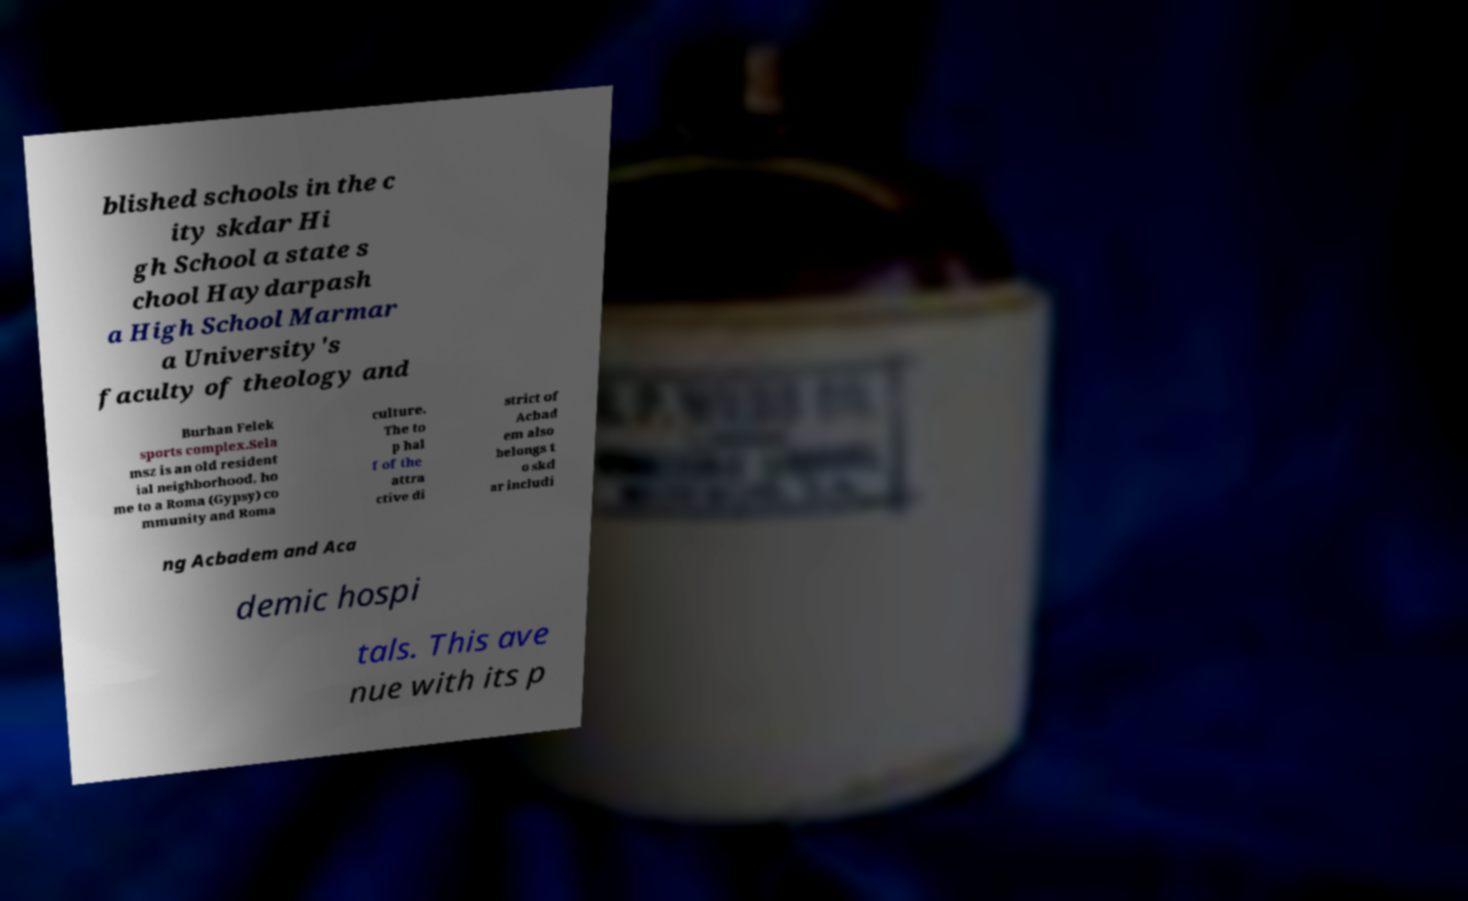Please read and relay the text visible in this image. What does it say? blished schools in the c ity skdar Hi gh School a state s chool Haydarpash a High School Marmar a University's faculty of theology and Burhan Felek sports complex.Sela msz is an old resident ial neighborhood, ho me to a Roma (Gypsy) co mmunity and Roma culture. The to p hal f of the attra ctive di strict of Acbad em also belongs t o skd ar includi ng Acbadem and Aca demic hospi tals. This ave nue with its p 